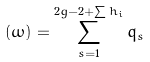<formula> <loc_0><loc_0><loc_500><loc_500>( \omega ) = \sum _ { s = 1 } ^ { 2 g - 2 + \sum h _ { i } } q _ { s }</formula> 